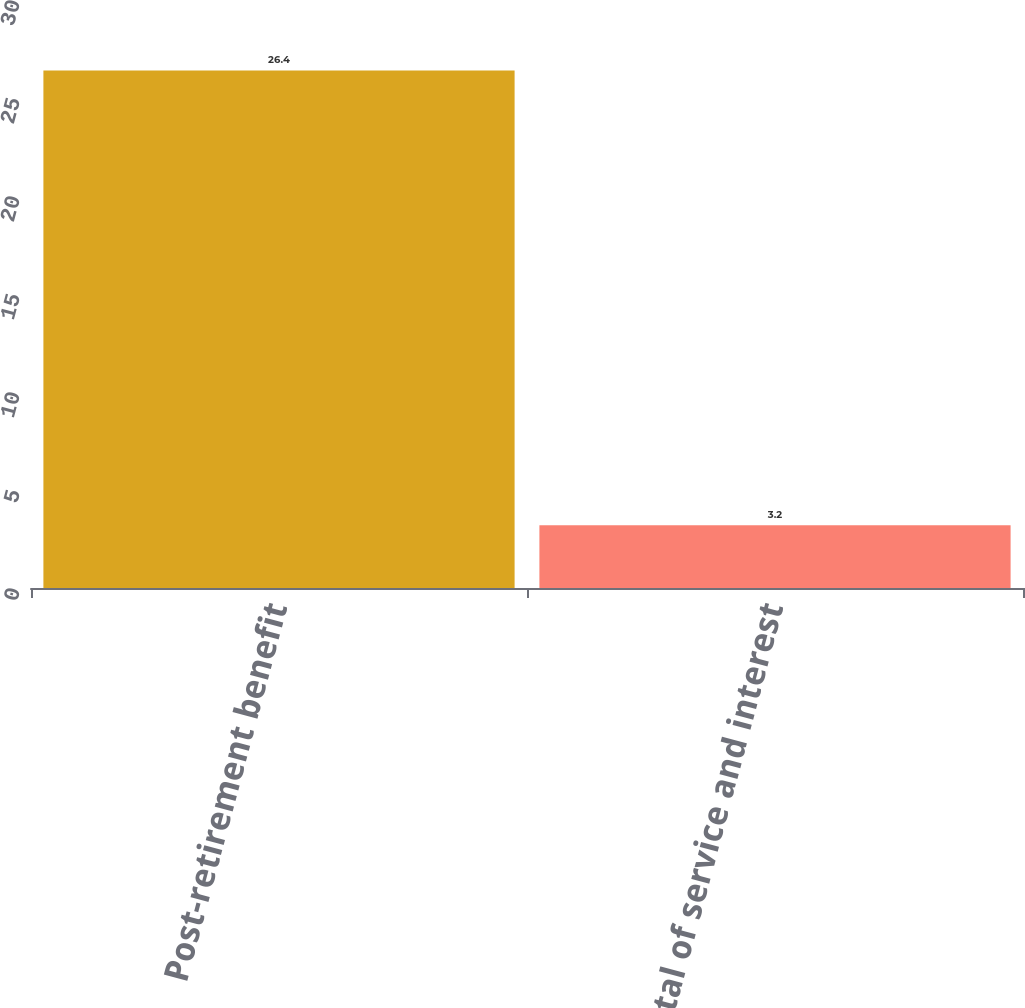Convert chart to OTSL. <chart><loc_0><loc_0><loc_500><loc_500><bar_chart><fcel>Post-retirement benefit<fcel>Total of service and interest<nl><fcel>26.4<fcel>3.2<nl></chart> 